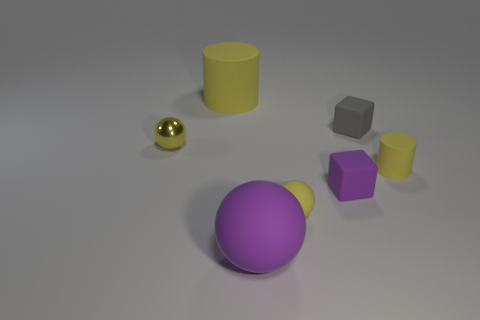Is the number of small yellow balls in front of the large yellow object greater than the number of small yellow metallic things?
Your answer should be compact. Yes. Is the size of the metal object the same as the purple ball?
Your response must be concise. No. There is a purple thing that is the same shape as the small yellow metal object; what is it made of?
Your answer should be very brief. Rubber. Are there any other things that are made of the same material as the large ball?
Keep it short and to the point. Yes. How many blue things are small matte cubes or small metal objects?
Make the answer very short. 0. There is a large thing that is in front of the small yellow rubber cylinder; what is its material?
Offer a very short reply. Rubber. Are there more tiny rubber things than green rubber objects?
Provide a short and direct response. Yes. Do the yellow rubber object in front of the tiny rubber cylinder and the tiny purple thing have the same shape?
Your answer should be very brief. No. How many things are both in front of the big rubber cylinder and left of the big purple matte ball?
Give a very brief answer. 1. How many large matte things are the same shape as the tiny purple thing?
Offer a very short reply. 0. 